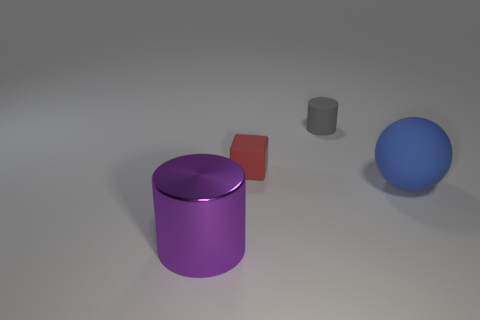Are there any other things that are made of the same material as the large cylinder?
Give a very brief answer. No. There is a cylinder that is behind the rubber cube; are there any tiny gray things that are behind it?
Provide a succinct answer. No. How many objects are either small rubber things that are to the left of the tiny cylinder or things that are in front of the red cube?
Keep it short and to the point. 3. Is there any other thing that is the same color as the big metal object?
Keep it short and to the point. No. What is the color of the cylinder that is behind the large object that is left of the big thing behind the purple metal cylinder?
Your answer should be compact. Gray. There is a cylinder to the right of the large object left of the gray rubber object; what is its size?
Offer a very short reply. Small. There is a object that is in front of the tiny red matte object and on the right side of the shiny thing; what is it made of?
Provide a succinct answer. Rubber. There is a blue rubber sphere; is its size the same as the matte object that is to the left of the gray matte thing?
Give a very brief answer. No. Is there a large block?
Offer a very short reply. No. There is another thing that is the same shape as the small gray object; what material is it?
Your answer should be compact. Metal. 